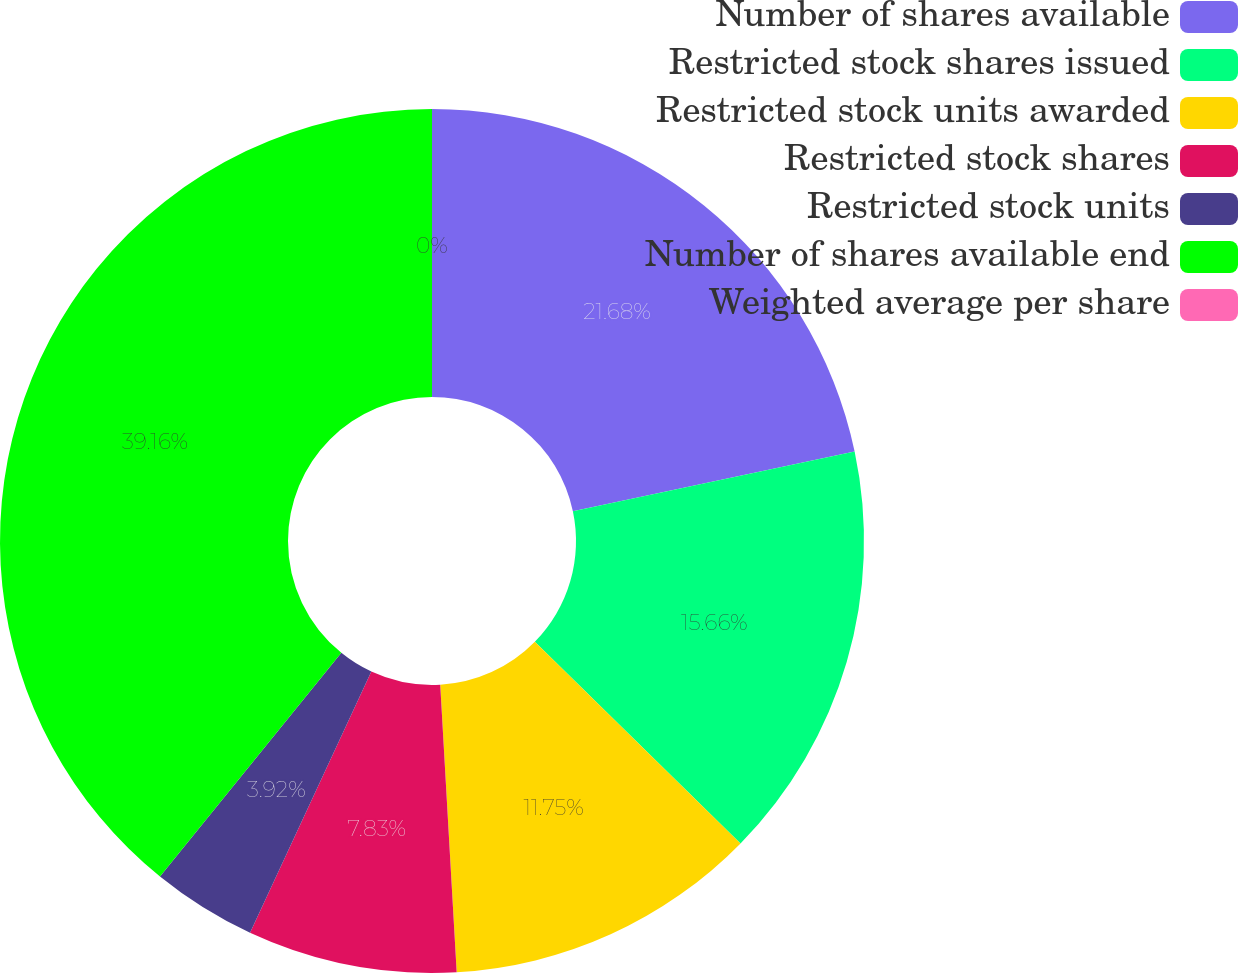Convert chart. <chart><loc_0><loc_0><loc_500><loc_500><pie_chart><fcel>Number of shares available<fcel>Restricted stock shares issued<fcel>Restricted stock units awarded<fcel>Restricted stock shares<fcel>Restricted stock units<fcel>Number of shares available end<fcel>Weighted average per share<nl><fcel>21.68%<fcel>15.66%<fcel>11.75%<fcel>7.83%<fcel>3.92%<fcel>39.16%<fcel>0.0%<nl></chart> 